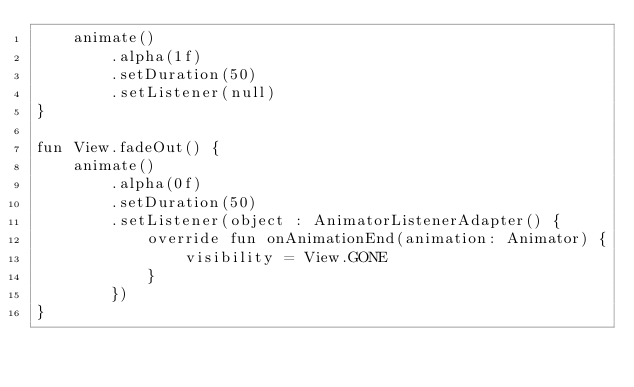<code> <loc_0><loc_0><loc_500><loc_500><_Kotlin_>    animate()
        .alpha(1f)
        .setDuration(50)
        .setListener(null)
}

fun View.fadeOut() {
    animate()
        .alpha(0f)
        .setDuration(50)
        .setListener(object : AnimatorListenerAdapter() {
            override fun onAnimationEnd(animation: Animator) {
                visibility = View.GONE
            }
        })
}</code> 